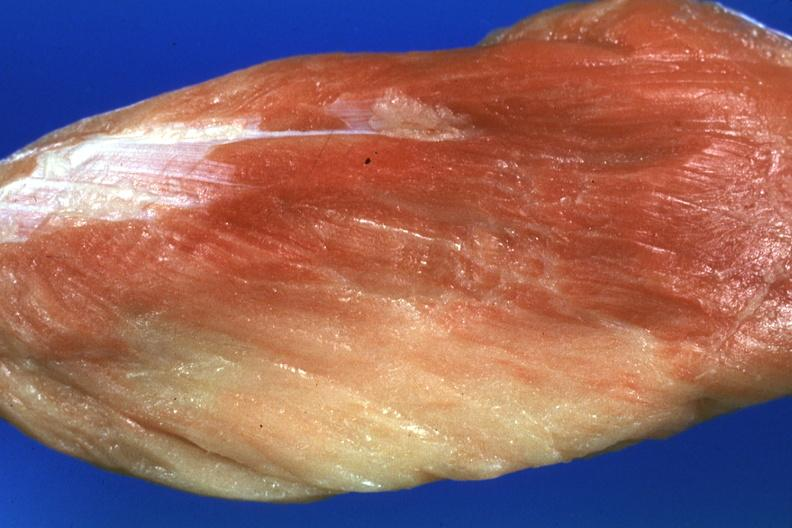s soft tissue present?
Answer the question using a single word or phrase. Yes 